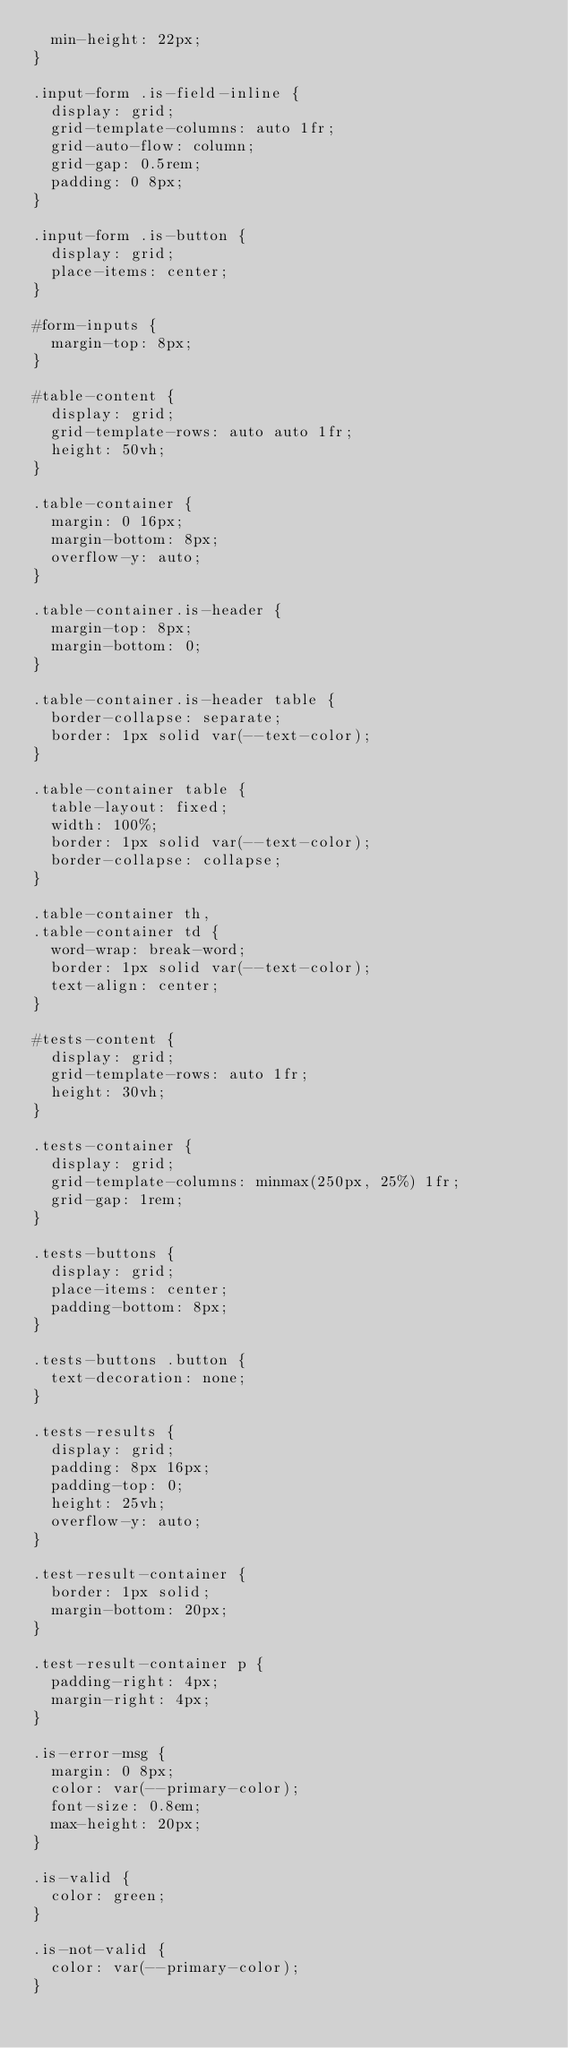<code> <loc_0><loc_0><loc_500><loc_500><_CSS_>  min-height: 22px;
}

.input-form .is-field-inline {
  display: grid;
  grid-template-columns: auto 1fr;
  grid-auto-flow: column;
  grid-gap: 0.5rem;
  padding: 0 8px;
}

.input-form .is-button {
  display: grid;
  place-items: center;
}

#form-inputs {
  margin-top: 8px;
}

#table-content {
  display: grid;
  grid-template-rows: auto auto 1fr;
  height: 50vh;
}

.table-container {
  margin: 0 16px;
  margin-bottom: 8px;
  overflow-y: auto;
}

.table-container.is-header {
  margin-top: 8px;
  margin-bottom: 0;
}

.table-container.is-header table {
  border-collapse: separate;
  border: 1px solid var(--text-color);
}

.table-container table {
  table-layout: fixed;
  width: 100%;
  border: 1px solid var(--text-color);
  border-collapse: collapse;
}

.table-container th,
.table-container td {
  word-wrap: break-word;
  border: 1px solid var(--text-color);
  text-align: center;
}

#tests-content {
  display: grid;
  grid-template-rows: auto 1fr;
  height: 30vh;
}

.tests-container {
  display: grid;
  grid-template-columns: minmax(250px, 25%) 1fr;
  grid-gap: 1rem;
}

.tests-buttons {
  display: grid;
  place-items: center;
  padding-bottom: 8px;
}

.tests-buttons .button {
  text-decoration: none;
}

.tests-results {
  display: grid;
  padding: 8px 16px;
  padding-top: 0;
  height: 25vh;
  overflow-y: auto;
}

.test-result-container {
  border: 1px solid;
  margin-bottom: 20px;
}

.test-result-container p {
  padding-right: 4px;
  margin-right: 4px;
}

.is-error-msg {
  margin: 0 8px;
  color: var(--primary-color);
  font-size: 0.8em;
  max-height: 20px;
}

.is-valid {
  color: green;
}

.is-not-valid {
  color: var(--primary-color);
}
</code> 